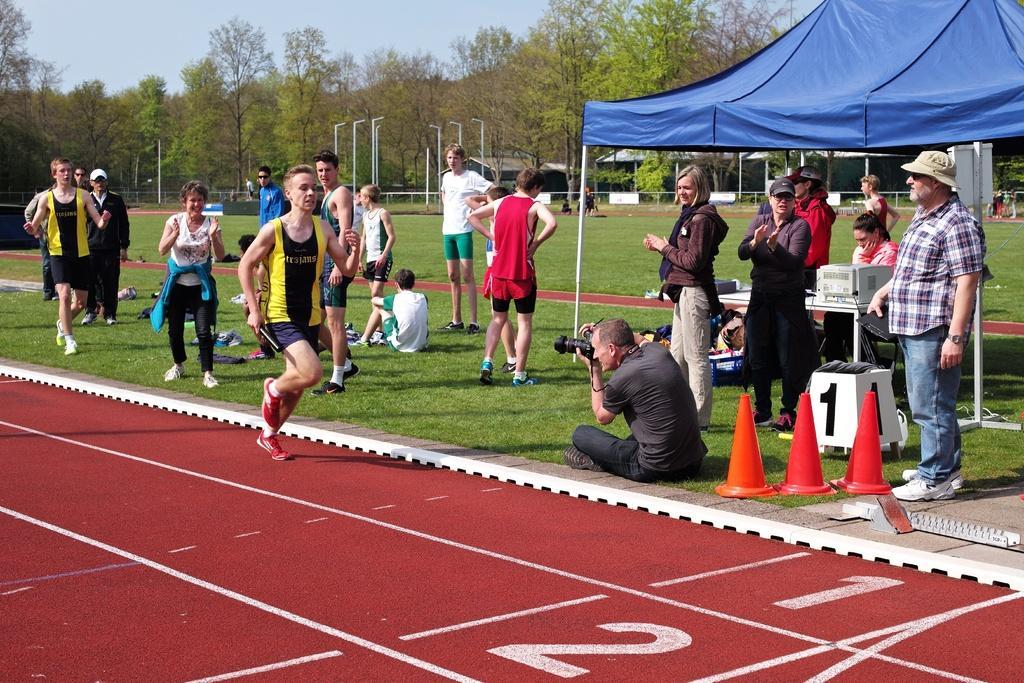How would you summarize this image in a sentence or two? In this picture, we can see a few people, some are standing, a few are sitting and a few are holding some objects and we can see the run path, ground with grass, and we can see some objects on the ground like chairs, sheds and we can see some objects on the table, we can see poles, trees, lights, houses and the sky 